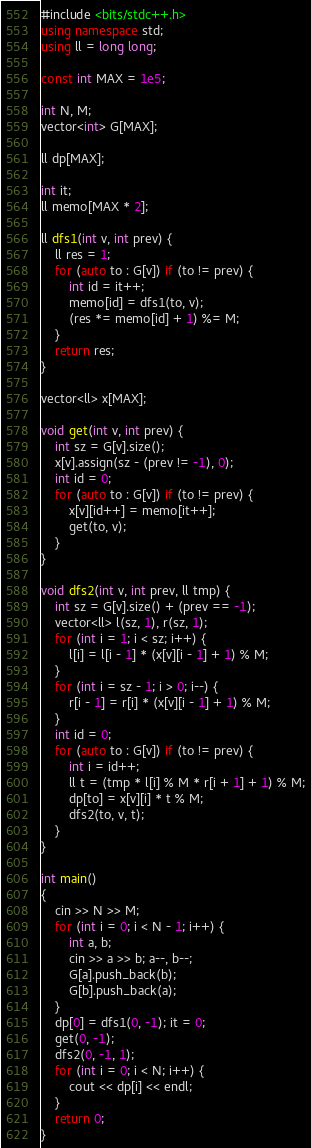Convert code to text. <code><loc_0><loc_0><loc_500><loc_500><_C++_>#include <bits/stdc++.h>
using namespace std;
using ll = long long;

const int MAX = 1e5;

int N, M;
vector<int> G[MAX];

ll dp[MAX];

int it;
ll memo[MAX * 2];

ll dfs1(int v, int prev) {
	ll res = 1;
	for (auto to : G[v]) if (to != prev) {
		int id = it++;
		memo[id] = dfs1(to, v);
		(res *= memo[id] + 1) %= M;
	}
	return res;
}

vector<ll> x[MAX];

void get(int v, int prev) {
	int sz = G[v].size();
	x[v].assign(sz - (prev != -1), 0);
	int id = 0;
	for (auto to : G[v]) if (to != prev) {
		x[v][id++] = memo[it++];
		get(to, v);
	}
}

void dfs2(int v, int prev, ll tmp) {
	int sz = G[v].size() + (prev == -1);
	vector<ll> l(sz, 1), r(sz, 1);
	for (int i = 1; i < sz; i++) {
		l[i] = l[i - 1] * (x[v][i - 1] + 1) % M;
	}
	for (int i = sz - 1; i > 0; i--) {
		r[i - 1] = r[i] * (x[v][i - 1] + 1) % M;
	}
	int id = 0;
	for (auto to : G[v]) if (to != prev) {
		int i = id++;
		ll t = (tmp * l[i] % M * r[i + 1] + 1) % M;
		dp[to] = x[v][i] * t % M;
		dfs2(to, v, t);
	}
}

int main()
{
	cin >> N >> M;
	for (int i = 0; i < N - 1; i++) {
		int a, b;
		cin >> a >> b; a--, b--;
		G[a].push_back(b);
		G[b].push_back(a);
	}
	dp[0] = dfs1(0, -1); it = 0;
	get(0, -1);
	dfs2(0, -1, 1);
	for (int i = 0; i < N; i++) {
		cout << dp[i] << endl;
	}
	return 0;
}
</code> 